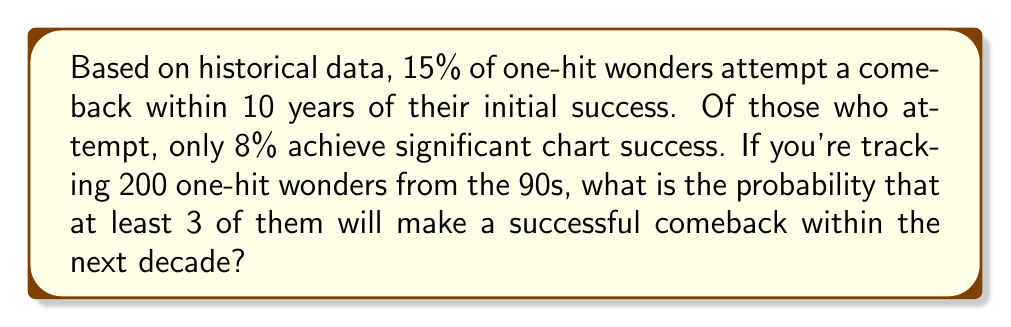Could you help me with this problem? Let's approach this step-by-step:

1) First, we need to calculate the probability of a single one-hit wonder making a successful comeback:
   $P(\text{successful comeback}) = P(\text{attempt}) \times P(\text{success | attempt})$
   $= 0.15 \times 0.08 = 0.012 = 1.2\%$

2) Now, we can model this as a binomial distribution. We want the probability of at least 3 successes out of 200 trials, where each trial has a 1.2% chance of success.

3) Let X be the number of successful comebacks. Then X ~ Bin(200, 0.012)

4) We want P(X ≥ 3) = 1 - P(X < 3) = 1 - [P(X = 0) + P(X = 1) + P(X = 2)]

5) Using the binomial probability formula:
   $P(X = k) = \binom{n}{k} p^k (1-p)^{n-k}$

   Where n = 200, p = 0.012

6) Calculating each probability:

   $P(X = 0) = \binom{200}{0} (0.012)^0 (0.988)^{200} = 0.0915$

   $P(X = 1) = \binom{200}{1} (0.012)^1 (0.988)^{199} = 0.2233$

   $P(X = 2) = \binom{200}{2} (0.012)^2 (0.988)^{198} = 0.2700$

7) Therefore:
   $P(X \geq 3) = 1 - (0.0915 + 0.2233 + 0.2700) = 1 - 0.5848 = 0.4152$

Thus, there is approximately a 41.52% chance that at least 3 out of 200 one-hit wonders will make a successful comeback within the next decade.
Answer: 0.4152 or 41.52% 